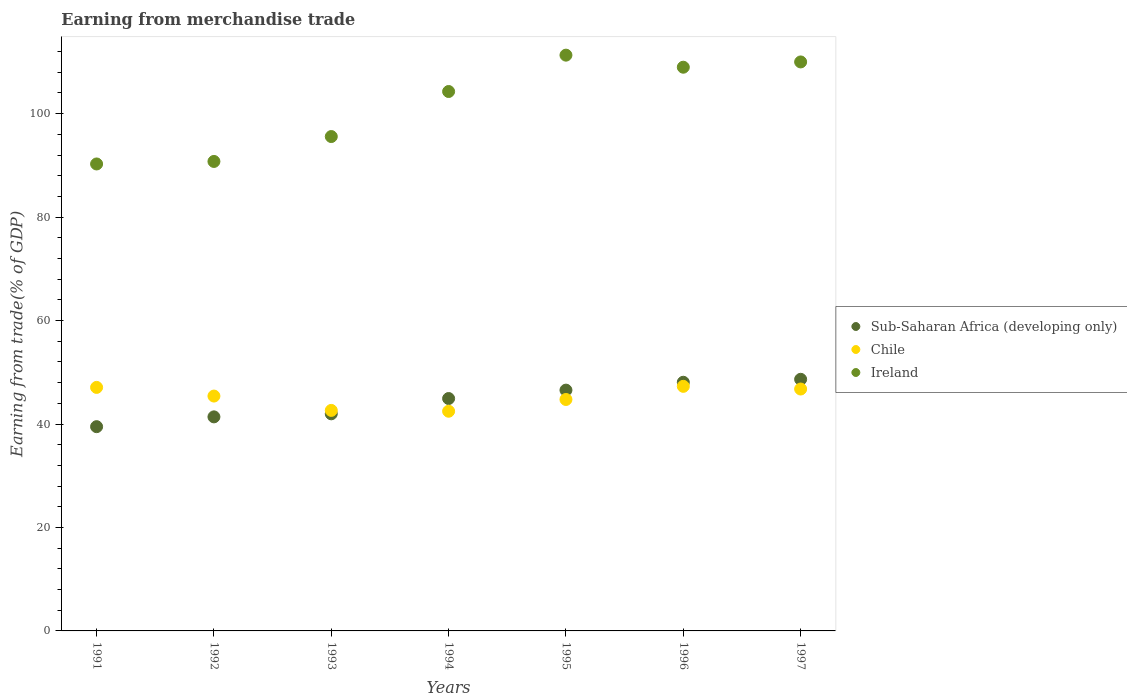What is the earnings from trade in Chile in 1991?
Keep it short and to the point. 47.08. Across all years, what is the maximum earnings from trade in Sub-Saharan Africa (developing only)?
Keep it short and to the point. 48.64. Across all years, what is the minimum earnings from trade in Chile?
Your answer should be very brief. 42.47. In which year was the earnings from trade in Ireland maximum?
Provide a short and direct response. 1995. In which year was the earnings from trade in Ireland minimum?
Offer a terse response. 1991. What is the total earnings from trade in Ireland in the graph?
Offer a very short reply. 711.17. What is the difference between the earnings from trade in Ireland in 1991 and that in 1997?
Your answer should be compact. -19.72. What is the difference between the earnings from trade in Ireland in 1997 and the earnings from trade in Sub-Saharan Africa (developing only) in 1996?
Ensure brevity in your answer.  61.93. What is the average earnings from trade in Chile per year?
Offer a terse response. 45.2. In the year 1997, what is the difference between the earnings from trade in Chile and earnings from trade in Sub-Saharan Africa (developing only)?
Your answer should be very brief. -1.88. What is the ratio of the earnings from trade in Chile in 1991 to that in 1995?
Your response must be concise. 1.05. Is the difference between the earnings from trade in Chile in 1991 and 1996 greater than the difference between the earnings from trade in Sub-Saharan Africa (developing only) in 1991 and 1996?
Your answer should be very brief. Yes. What is the difference between the highest and the second highest earnings from trade in Chile?
Your response must be concise. 0.2. What is the difference between the highest and the lowest earnings from trade in Chile?
Provide a succinct answer. 4.81. In how many years, is the earnings from trade in Chile greater than the average earnings from trade in Chile taken over all years?
Your answer should be very brief. 4. Is the earnings from trade in Ireland strictly greater than the earnings from trade in Chile over the years?
Offer a terse response. Yes. How many dotlines are there?
Offer a very short reply. 3. Are the values on the major ticks of Y-axis written in scientific E-notation?
Your answer should be compact. No. Where does the legend appear in the graph?
Ensure brevity in your answer.  Center right. How many legend labels are there?
Your answer should be compact. 3. How are the legend labels stacked?
Provide a short and direct response. Vertical. What is the title of the graph?
Keep it short and to the point. Earning from merchandise trade. What is the label or title of the X-axis?
Give a very brief answer. Years. What is the label or title of the Y-axis?
Make the answer very short. Earning from trade(% of GDP). What is the Earning from trade(% of GDP) in Sub-Saharan Africa (developing only) in 1991?
Give a very brief answer. 39.49. What is the Earning from trade(% of GDP) in Chile in 1991?
Make the answer very short. 47.08. What is the Earning from trade(% of GDP) of Ireland in 1991?
Keep it short and to the point. 90.27. What is the Earning from trade(% of GDP) in Sub-Saharan Africa (developing only) in 1992?
Offer a terse response. 41.38. What is the Earning from trade(% of GDP) of Chile in 1992?
Your answer should be very brief. 45.4. What is the Earning from trade(% of GDP) in Ireland in 1992?
Provide a succinct answer. 90.76. What is the Earning from trade(% of GDP) of Sub-Saharan Africa (developing only) in 1993?
Keep it short and to the point. 41.97. What is the Earning from trade(% of GDP) in Chile in 1993?
Your response must be concise. 42.63. What is the Earning from trade(% of GDP) in Ireland in 1993?
Your answer should be compact. 95.57. What is the Earning from trade(% of GDP) in Sub-Saharan Africa (developing only) in 1994?
Keep it short and to the point. 44.93. What is the Earning from trade(% of GDP) of Chile in 1994?
Your answer should be very brief. 42.47. What is the Earning from trade(% of GDP) of Ireland in 1994?
Provide a short and direct response. 104.28. What is the Earning from trade(% of GDP) in Sub-Saharan Africa (developing only) in 1995?
Provide a succinct answer. 46.55. What is the Earning from trade(% of GDP) in Chile in 1995?
Your answer should be very brief. 44.74. What is the Earning from trade(% of GDP) of Ireland in 1995?
Provide a short and direct response. 111.31. What is the Earning from trade(% of GDP) in Sub-Saharan Africa (developing only) in 1996?
Give a very brief answer. 48.07. What is the Earning from trade(% of GDP) in Chile in 1996?
Give a very brief answer. 47.28. What is the Earning from trade(% of GDP) of Ireland in 1996?
Make the answer very short. 108.98. What is the Earning from trade(% of GDP) in Sub-Saharan Africa (developing only) in 1997?
Make the answer very short. 48.64. What is the Earning from trade(% of GDP) of Chile in 1997?
Offer a terse response. 46.76. What is the Earning from trade(% of GDP) of Ireland in 1997?
Ensure brevity in your answer.  110. Across all years, what is the maximum Earning from trade(% of GDP) in Sub-Saharan Africa (developing only)?
Offer a terse response. 48.64. Across all years, what is the maximum Earning from trade(% of GDP) in Chile?
Provide a succinct answer. 47.28. Across all years, what is the maximum Earning from trade(% of GDP) in Ireland?
Your answer should be very brief. 111.31. Across all years, what is the minimum Earning from trade(% of GDP) of Sub-Saharan Africa (developing only)?
Keep it short and to the point. 39.49. Across all years, what is the minimum Earning from trade(% of GDP) of Chile?
Offer a very short reply. 42.47. Across all years, what is the minimum Earning from trade(% of GDP) in Ireland?
Keep it short and to the point. 90.27. What is the total Earning from trade(% of GDP) in Sub-Saharan Africa (developing only) in the graph?
Ensure brevity in your answer.  311.03. What is the total Earning from trade(% of GDP) of Chile in the graph?
Provide a short and direct response. 316.37. What is the total Earning from trade(% of GDP) of Ireland in the graph?
Your answer should be very brief. 711.17. What is the difference between the Earning from trade(% of GDP) in Sub-Saharan Africa (developing only) in 1991 and that in 1992?
Keep it short and to the point. -1.9. What is the difference between the Earning from trade(% of GDP) in Chile in 1991 and that in 1992?
Give a very brief answer. 1.68. What is the difference between the Earning from trade(% of GDP) of Ireland in 1991 and that in 1992?
Provide a short and direct response. -0.49. What is the difference between the Earning from trade(% of GDP) of Sub-Saharan Africa (developing only) in 1991 and that in 1993?
Your response must be concise. -2.49. What is the difference between the Earning from trade(% of GDP) in Chile in 1991 and that in 1993?
Your response must be concise. 4.45. What is the difference between the Earning from trade(% of GDP) of Ireland in 1991 and that in 1993?
Provide a short and direct response. -5.3. What is the difference between the Earning from trade(% of GDP) in Sub-Saharan Africa (developing only) in 1991 and that in 1994?
Offer a very short reply. -5.44. What is the difference between the Earning from trade(% of GDP) in Chile in 1991 and that in 1994?
Your answer should be very brief. 4.61. What is the difference between the Earning from trade(% of GDP) in Ireland in 1991 and that in 1994?
Provide a succinct answer. -14.01. What is the difference between the Earning from trade(% of GDP) of Sub-Saharan Africa (developing only) in 1991 and that in 1995?
Keep it short and to the point. -7.06. What is the difference between the Earning from trade(% of GDP) in Chile in 1991 and that in 1995?
Your answer should be very brief. 2.34. What is the difference between the Earning from trade(% of GDP) of Ireland in 1991 and that in 1995?
Provide a short and direct response. -21.04. What is the difference between the Earning from trade(% of GDP) in Sub-Saharan Africa (developing only) in 1991 and that in 1996?
Offer a terse response. -8.59. What is the difference between the Earning from trade(% of GDP) in Chile in 1991 and that in 1996?
Make the answer very short. -0.2. What is the difference between the Earning from trade(% of GDP) in Ireland in 1991 and that in 1996?
Offer a very short reply. -18.7. What is the difference between the Earning from trade(% of GDP) in Sub-Saharan Africa (developing only) in 1991 and that in 1997?
Make the answer very short. -9.16. What is the difference between the Earning from trade(% of GDP) of Chile in 1991 and that in 1997?
Provide a succinct answer. 0.32. What is the difference between the Earning from trade(% of GDP) of Ireland in 1991 and that in 1997?
Your response must be concise. -19.72. What is the difference between the Earning from trade(% of GDP) of Sub-Saharan Africa (developing only) in 1992 and that in 1993?
Give a very brief answer. -0.59. What is the difference between the Earning from trade(% of GDP) of Chile in 1992 and that in 1993?
Offer a very short reply. 2.77. What is the difference between the Earning from trade(% of GDP) of Ireland in 1992 and that in 1993?
Your answer should be very brief. -4.81. What is the difference between the Earning from trade(% of GDP) of Sub-Saharan Africa (developing only) in 1992 and that in 1994?
Keep it short and to the point. -3.54. What is the difference between the Earning from trade(% of GDP) in Chile in 1992 and that in 1994?
Give a very brief answer. 2.93. What is the difference between the Earning from trade(% of GDP) in Ireland in 1992 and that in 1994?
Ensure brevity in your answer.  -13.52. What is the difference between the Earning from trade(% of GDP) of Sub-Saharan Africa (developing only) in 1992 and that in 1995?
Provide a short and direct response. -5.17. What is the difference between the Earning from trade(% of GDP) of Chile in 1992 and that in 1995?
Make the answer very short. 0.66. What is the difference between the Earning from trade(% of GDP) of Ireland in 1992 and that in 1995?
Offer a terse response. -20.55. What is the difference between the Earning from trade(% of GDP) in Sub-Saharan Africa (developing only) in 1992 and that in 1996?
Keep it short and to the point. -6.69. What is the difference between the Earning from trade(% of GDP) in Chile in 1992 and that in 1996?
Offer a terse response. -1.88. What is the difference between the Earning from trade(% of GDP) of Ireland in 1992 and that in 1996?
Offer a very short reply. -18.22. What is the difference between the Earning from trade(% of GDP) of Sub-Saharan Africa (developing only) in 1992 and that in 1997?
Offer a terse response. -7.26. What is the difference between the Earning from trade(% of GDP) of Chile in 1992 and that in 1997?
Provide a short and direct response. -1.36. What is the difference between the Earning from trade(% of GDP) in Ireland in 1992 and that in 1997?
Give a very brief answer. -19.24. What is the difference between the Earning from trade(% of GDP) of Sub-Saharan Africa (developing only) in 1993 and that in 1994?
Provide a short and direct response. -2.95. What is the difference between the Earning from trade(% of GDP) in Chile in 1993 and that in 1994?
Provide a short and direct response. 0.16. What is the difference between the Earning from trade(% of GDP) in Ireland in 1993 and that in 1994?
Keep it short and to the point. -8.71. What is the difference between the Earning from trade(% of GDP) of Sub-Saharan Africa (developing only) in 1993 and that in 1995?
Your answer should be very brief. -4.58. What is the difference between the Earning from trade(% of GDP) in Chile in 1993 and that in 1995?
Your answer should be compact. -2.11. What is the difference between the Earning from trade(% of GDP) in Ireland in 1993 and that in 1995?
Provide a short and direct response. -15.74. What is the difference between the Earning from trade(% of GDP) of Sub-Saharan Africa (developing only) in 1993 and that in 1996?
Provide a short and direct response. -6.1. What is the difference between the Earning from trade(% of GDP) of Chile in 1993 and that in 1996?
Offer a terse response. -4.65. What is the difference between the Earning from trade(% of GDP) of Ireland in 1993 and that in 1996?
Offer a very short reply. -13.4. What is the difference between the Earning from trade(% of GDP) in Sub-Saharan Africa (developing only) in 1993 and that in 1997?
Offer a terse response. -6.67. What is the difference between the Earning from trade(% of GDP) in Chile in 1993 and that in 1997?
Offer a very short reply. -4.13. What is the difference between the Earning from trade(% of GDP) in Ireland in 1993 and that in 1997?
Your response must be concise. -14.42. What is the difference between the Earning from trade(% of GDP) of Sub-Saharan Africa (developing only) in 1994 and that in 1995?
Make the answer very short. -1.62. What is the difference between the Earning from trade(% of GDP) in Chile in 1994 and that in 1995?
Your response must be concise. -2.27. What is the difference between the Earning from trade(% of GDP) of Ireland in 1994 and that in 1995?
Your response must be concise. -7.03. What is the difference between the Earning from trade(% of GDP) of Sub-Saharan Africa (developing only) in 1994 and that in 1996?
Your response must be concise. -3.14. What is the difference between the Earning from trade(% of GDP) in Chile in 1994 and that in 1996?
Your answer should be very brief. -4.81. What is the difference between the Earning from trade(% of GDP) in Ireland in 1994 and that in 1996?
Your answer should be very brief. -4.7. What is the difference between the Earning from trade(% of GDP) of Sub-Saharan Africa (developing only) in 1994 and that in 1997?
Make the answer very short. -3.72. What is the difference between the Earning from trade(% of GDP) of Chile in 1994 and that in 1997?
Give a very brief answer. -4.29. What is the difference between the Earning from trade(% of GDP) in Ireland in 1994 and that in 1997?
Your response must be concise. -5.72. What is the difference between the Earning from trade(% of GDP) in Sub-Saharan Africa (developing only) in 1995 and that in 1996?
Offer a terse response. -1.52. What is the difference between the Earning from trade(% of GDP) of Chile in 1995 and that in 1996?
Offer a very short reply. -2.54. What is the difference between the Earning from trade(% of GDP) in Ireland in 1995 and that in 1996?
Keep it short and to the point. 2.33. What is the difference between the Earning from trade(% of GDP) in Sub-Saharan Africa (developing only) in 1995 and that in 1997?
Keep it short and to the point. -2.09. What is the difference between the Earning from trade(% of GDP) of Chile in 1995 and that in 1997?
Offer a very short reply. -2.02. What is the difference between the Earning from trade(% of GDP) of Ireland in 1995 and that in 1997?
Provide a succinct answer. 1.31. What is the difference between the Earning from trade(% of GDP) of Sub-Saharan Africa (developing only) in 1996 and that in 1997?
Your response must be concise. -0.57. What is the difference between the Earning from trade(% of GDP) of Chile in 1996 and that in 1997?
Ensure brevity in your answer.  0.52. What is the difference between the Earning from trade(% of GDP) in Ireland in 1996 and that in 1997?
Ensure brevity in your answer.  -1.02. What is the difference between the Earning from trade(% of GDP) of Sub-Saharan Africa (developing only) in 1991 and the Earning from trade(% of GDP) of Chile in 1992?
Ensure brevity in your answer.  -5.92. What is the difference between the Earning from trade(% of GDP) of Sub-Saharan Africa (developing only) in 1991 and the Earning from trade(% of GDP) of Ireland in 1992?
Offer a very short reply. -51.27. What is the difference between the Earning from trade(% of GDP) in Chile in 1991 and the Earning from trade(% of GDP) in Ireland in 1992?
Provide a succinct answer. -43.68. What is the difference between the Earning from trade(% of GDP) of Sub-Saharan Africa (developing only) in 1991 and the Earning from trade(% of GDP) of Chile in 1993?
Keep it short and to the point. -3.14. What is the difference between the Earning from trade(% of GDP) of Sub-Saharan Africa (developing only) in 1991 and the Earning from trade(% of GDP) of Ireland in 1993?
Your response must be concise. -56.09. What is the difference between the Earning from trade(% of GDP) of Chile in 1991 and the Earning from trade(% of GDP) of Ireland in 1993?
Offer a very short reply. -48.49. What is the difference between the Earning from trade(% of GDP) in Sub-Saharan Africa (developing only) in 1991 and the Earning from trade(% of GDP) in Chile in 1994?
Ensure brevity in your answer.  -2.98. What is the difference between the Earning from trade(% of GDP) of Sub-Saharan Africa (developing only) in 1991 and the Earning from trade(% of GDP) of Ireland in 1994?
Your answer should be very brief. -64.79. What is the difference between the Earning from trade(% of GDP) in Chile in 1991 and the Earning from trade(% of GDP) in Ireland in 1994?
Provide a short and direct response. -57.2. What is the difference between the Earning from trade(% of GDP) of Sub-Saharan Africa (developing only) in 1991 and the Earning from trade(% of GDP) of Chile in 1995?
Ensure brevity in your answer.  -5.26. What is the difference between the Earning from trade(% of GDP) in Sub-Saharan Africa (developing only) in 1991 and the Earning from trade(% of GDP) in Ireland in 1995?
Keep it short and to the point. -71.82. What is the difference between the Earning from trade(% of GDP) in Chile in 1991 and the Earning from trade(% of GDP) in Ireland in 1995?
Provide a succinct answer. -64.23. What is the difference between the Earning from trade(% of GDP) in Sub-Saharan Africa (developing only) in 1991 and the Earning from trade(% of GDP) in Chile in 1996?
Give a very brief answer. -7.8. What is the difference between the Earning from trade(% of GDP) in Sub-Saharan Africa (developing only) in 1991 and the Earning from trade(% of GDP) in Ireland in 1996?
Make the answer very short. -69.49. What is the difference between the Earning from trade(% of GDP) of Chile in 1991 and the Earning from trade(% of GDP) of Ireland in 1996?
Give a very brief answer. -61.9. What is the difference between the Earning from trade(% of GDP) in Sub-Saharan Africa (developing only) in 1991 and the Earning from trade(% of GDP) in Chile in 1997?
Your answer should be compact. -7.28. What is the difference between the Earning from trade(% of GDP) of Sub-Saharan Africa (developing only) in 1991 and the Earning from trade(% of GDP) of Ireland in 1997?
Your response must be concise. -70.51. What is the difference between the Earning from trade(% of GDP) of Chile in 1991 and the Earning from trade(% of GDP) of Ireland in 1997?
Offer a very short reply. -62.92. What is the difference between the Earning from trade(% of GDP) of Sub-Saharan Africa (developing only) in 1992 and the Earning from trade(% of GDP) of Chile in 1993?
Your answer should be very brief. -1.25. What is the difference between the Earning from trade(% of GDP) of Sub-Saharan Africa (developing only) in 1992 and the Earning from trade(% of GDP) of Ireland in 1993?
Keep it short and to the point. -54.19. What is the difference between the Earning from trade(% of GDP) of Chile in 1992 and the Earning from trade(% of GDP) of Ireland in 1993?
Offer a very short reply. -50.17. What is the difference between the Earning from trade(% of GDP) in Sub-Saharan Africa (developing only) in 1992 and the Earning from trade(% of GDP) in Chile in 1994?
Keep it short and to the point. -1.09. What is the difference between the Earning from trade(% of GDP) of Sub-Saharan Africa (developing only) in 1992 and the Earning from trade(% of GDP) of Ireland in 1994?
Make the answer very short. -62.9. What is the difference between the Earning from trade(% of GDP) in Chile in 1992 and the Earning from trade(% of GDP) in Ireland in 1994?
Provide a short and direct response. -58.88. What is the difference between the Earning from trade(% of GDP) in Sub-Saharan Africa (developing only) in 1992 and the Earning from trade(% of GDP) in Chile in 1995?
Give a very brief answer. -3.36. What is the difference between the Earning from trade(% of GDP) of Sub-Saharan Africa (developing only) in 1992 and the Earning from trade(% of GDP) of Ireland in 1995?
Offer a very short reply. -69.93. What is the difference between the Earning from trade(% of GDP) of Chile in 1992 and the Earning from trade(% of GDP) of Ireland in 1995?
Make the answer very short. -65.91. What is the difference between the Earning from trade(% of GDP) of Sub-Saharan Africa (developing only) in 1992 and the Earning from trade(% of GDP) of Chile in 1996?
Your answer should be very brief. -5.9. What is the difference between the Earning from trade(% of GDP) of Sub-Saharan Africa (developing only) in 1992 and the Earning from trade(% of GDP) of Ireland in 1996?
Your response must be concise. -67.59. What is the difference between the Earning from trade(% of GDP) of Chile in 1992 and the Earning from trade(% of GDP) of Ireland in 1996?
Offer a very short reply. -63.57. What is the difference between the Earning from trade(% of GDP) in Sub-Saharan Africa (developing only) in 1992 and the Earning from trade(% of GDP) in Chile in 1997?
Offer a terse response. -5.38. What is the difference between the Earning from trade(% of GDP) in Sub-Saharan Africa (developing only) in 1992 and the Earning from trade(% of GDP) in Ireland in 1997?
Provide a succinct answer. -68.62. What is the difference between the Earning from trade(% of GDP) of Chile in 1992 and the Earning from trade(% of GDP) of Ireland in 1997?
Offer a very short reply. -64.59. What is the difference between the Earning from trade(% of GDP) in Sub-Saharan Africa (developing only) in 1993 and the Earning from trade(% of GDP) in Chile in 1994?
Offer a terse response. -0.5. What is the difference between the Earning from trade(% of GDP) in Sub-Saharan Africa (developing only) in 1993 and the Earning from trade(% of GDP) in Ireland in 1994?
Provide a succinct answer. -62.31. What is the difference between the Earning from trade(% of GDP) in Chile in 1993 and the Earning from trade(% of GDP) in Ireland in 1994?
Give a very brief answer. -61.65. What is the difference between the Earning from trade(% of GDP) in Sub-Saharan Africa (developing only) in 1993 and the Earning from trade(% of GDP) in Chile in 1995?
Ensure brevity in your answer.  -2.77. What is the difference between the Earning from trade(% of GDP) in Sub-Saharan Africa (developing only) in 1993 and the Earning from trade(% of GDP) in Ireland in 1995?
Your response must be concise. -69.34. What is the difference between the Earning from trade(% of GDP) in Chile in 1993 and the Earning from trade(% of GDP) in Ireland in 1995?
Offer a very short reply. -68.68. What is the difference between the Earning from trade(% of GDP) of Sub-Saharan Africa (developing only) in 1993 and the Earning from trade(% of GDP) of Chile in 1996?
Your answer should be compact. -5.31. What is the difference between the Earning from trade(% of GDP) in Sub-Saharan Africa (developing only) in 1993 and the Earning from trade(% of GDP) in Ireland in 1996?
Your response must be concise. -67. What is the difference between the Earning from trade(% of GDP) of Chile in 1993 and the Earning from trade(% of GDP) of Ireland in 1996?
Your answer should be compact. -66.35. What is the difference between the Earning from trade(% of GDP) of Sub-Saharan Africa (developing only) in 1993 and the Earning from trade(% of GDP) of Chile in 1997?
Offer a terse response. -4.79. What is the difference between the Earning from trade(% of GDP) in Sub-Saharan Africa (developing only) in 1993 and the Earning from trade(% of GDP) in Ireland in 1997?
Offer a very short reply. -68.03. What is the difference between the Earning from trade(% of GDP) of Chile in 1993 and the Earning from trade(% of GDP) of Ireland in 1997?
Your answer should be compact. -67.37. What is the difference between the Earning from trade(% of GDP) of Sub-Saharan Africa (developing only) in 1994 and the Earning from trade(% of GDP) of Chile in 1995?
Your answer should be very brief. 0.18. What is the difference between the Earning from trade(% of GDP) in Sub-Saharan Africa (developing only) in 1994 and the Earning from trade(% of GDP) in Ireland in 1995?
Keep it short and to the point. -66.38. What is the difference between the Earning from trade(% of GDP) of Chile in 1994 and the Earning from trade(% of GDP) of Ireland in 1995?
Offer a very short reply. -68.84. What is the difference between the Earning from trade(% of GDP) in Sub-Saharan Africa (developing only) in 1994 and the Earning from trade(% of GDP) in Chile in 1996?
Provide a short and direct response. -2.36. What is the difference between the Earning from trade(% of GDP) in Sub-Saharan Africa (developing only) in 1994 and the Earning from trade(% of GDP) in Ireland in 1996?
Make the answer very short. -64.05. What is the difference between the Earning from trade(% of GDP) in Chile in 1994 and the Earning from trade(% of GDP) in Ireland in 1996?
Make the answer very short. -66.51. What is the difference between the Earning from trade(% of GDP) in Sub-Saharan Africa (developing only) in 1994 and the Earning from trade(% of GDP) in Chile in 1997?
Provide a short and direct response. -1.84. What is the difference between the Earning from trade(% of GDP) of Sub-Saharan Africa (developing only) in 1994 and the Earning from trade(% of GDP) of Ireland in 1997?
Make the answer very short. -65.07. What is the difference between the Earning from trade(% of GDP) in Chile in 1994 and the Earning from trade(% of GDP) in Ireland in 1997?
Offer a terse response. -67.53. What is the difference between the Earning from trade(% of GDP) of Sub-Saharan Africa (developing only) in 1995 and the Earning from trade(% of GDP) of Chile in 1996?
Offer a terse response. -0.73. What is the difference between the Earning from trade(% of GDP) of Sub-Saharan Africa (developing only) in 1995 and the Earning from trade(% of GDP) of Ireland in 1996?
Ensure brevity in your answer.  -62.43. What is the difference between the Earning from trade(% of GDP) of Chile in 1995 and the Earning from trade(% of GDP) of Ireland in 1996?
Provide a succinct answer. -64.23. What is the difference between the Earning from trade(% of GDP) of Sub-Saharan Africa (developing only) in 1995 and the Earning from trade(% of GDP) of Chile in 1997?
Give a very brief answer. -0.21. What is the difference between the Earning from trade(% of GDP) of Sub-Saharan Africa (developing only) in 1995 and the Earning from trade(% of GDP) of Ireland in 1997?
Your answer should be compact. -63.45. What is the difference between the Earning from trade(% of GDP) in Chile in 1995 and the Earning from trade(% of GDP) in Ireland in 1997?
Provide a short and direct response. -65.25. What is the difference between the Earning from trade(% of GDP) in Sub-Saharan Africa (developing only) in 1996 and the Earning from trade(% of GDP) in Chile in 1997?
Provide a short and direct response. 1.31. What is the difference between the Earning from trade(% of GDP) of Sub-Saharan Africa (developing only) in 1996 and the Earning from trade(% of GDP) of Ireland in 1997?
Make the answer very short. -61.93. What is the difference between the Earning from trade(% of GDP) in Chile in 1996 and the Earning from trade(% of GDP) in Ireland in 1997?
Your answer should be compact. -62.71. What is the average Earning from trade(% of GDP) in Sub-Saharan Africa (developing only) per year?
Provide a succinct answer. 44.43. What is the average Earning from trade(% of GDP) of Chile per year?
Ensure brevity in your answer.  45.2. What is the average Earning from trade(% of GDP) in Ireland per year?
Your answer should be compact. 101.59. In the year 1991, what is the difference between the Earning from trade(% of GDP) of Sub-Saharan Africa (developing only) and Earning from trade(% of GDP) of Chile?
Offer a terse response. -7.59. In the year 1991, what is the difference between the Earning from trade(% of GDP) of Sub-Saharan Africa (developing only) and Earning from trade(% of GDP) of Ireland?
Keep it short and to the point. -50.79. In the year 1991, what is the difference between the Earning from trade(% of GDP) in Chile and Earning from trade(% of GDP) in Ireland?
Offer a very short reply. -43.19. In the year 1992, what is the difference between the Earning from trade(% of GDP) of Sub-Saharan Africa (developing only) and Earning from trade(% of GDP) of Chile?
Make the answer very short. -4.02. In the year 1992, what is the difference between the Earning from trade(% of GDP) in Sub-Saharan Africa (developing only) and Earning from trade(% of GDP) in Ireland?
Keep it short and to the point. -49.38. In the year 1992, what is the difference between the Earning from trade(% of GDP) of Chile and Earning from trade(% of GDP) of Ireland?
Make the answer very short. -45.36. In the year 1993, what is the difference between the Earning from trade(% of GDP) of Sub-Saharan Africa (developing only) and Earning from trade(% of GDP) of Chile?
Offer a terse response. -0.66. In the year 1993, what is the difference between the Earning from trade(% of GDP) in Sub-Saharan Africa (developing only) and Earning from trade(% of GDP) in Ireland?
Your response must be concise. -53.6. In the year 1993, what is the difference between the Earning from trade(% of GDP) in Chile and Earning from trade(% of GDP) in Ireland?
Your response must be concise. -52.94. In the year 1994, what is the difference between the Earning from trade(% of GDP) of Sub-Saharan Africa (developing only) and Earning from trade(% of GDP) of Chile?
Provide a short and direct response. 2.46. In the year 1994, what is the difference between the Earning from trade(% of GDP) of Sub-Saharan Africa (developing only) and Earning from trade(% of GDP) of Ireland?
Your answer should be compact. -59.35. In the year 1994, what is the difference between the Earning from trade(% of GDP) in Chile and Earning from trade(% of GDP) in Ireland?
Provide a succinct answer. -61.81. In the year 1995, what is the difference between the Earning from trade(% of GDP) of Sub-Saharan Africa (developing only) and Earning from trade(% of GDP) of Chile?
Make the answer very short. 1.81. In the year 1995, what is the difference between the Earning from trade(% of GDP) of Sub-Saharan Africa (developing only) and Earning from trade(% of GDP) of Ireland?
Offer a terse response. -64.76. In the year 1995, what is the difference between the Earning from trade(% of GDP) in Chile and Earning from trade(% of GDP) in Ireland?
Your response must be concise. -66.57. In the year 1996, what is the difference between the Earning from trade(% of GDP) in Sub-Saharan Africa (developing only) and Earning from trade(% of GDP) in Chile?
Your answer should be very brief. 0.79. In the year 1996, what is the difference between the Earning from trade(% of GDP) in Sub-Saharan Africa (developing only) and Earning from trade(% of GDP) in Ireland?
Keep it short and to the point. -60.91. In the year 1996, what is the difference between the Earning from trade(% of GDP) of Chile and Earning from trade(% of GDP) of Ireland?
Your response must be concise. -61.69. In the year 1997, what is the difference between the Earning from trade(% of GDP) in Sub-Saharan Africa (developing only) and Earning from trade(% of GDP) in Chile?
Offer a very short reply. 1.88. In the year 1997, what is the difference between the Earning from trade(% of GDP) of Sub-Saharan Africa (developing only) and Earning from trade(% of GDP) of Ireland?
Provide a short and direct response. -61.35. In the year 1997, what is the difference between the Earning from trade(% of GDP) of Chile and Earning from trade(% of GDP) of Ireland?
Give a very brief answer. -63.23. What is the ratio of the Earning from trade(% of GDP) of Sub-Saharan Africa (developing only) in 1991 to that in 1992?
Give a very brief answer. 0.95. What is the ratio of the Earning from trade(% of GDP) of Chile in 1991 to that in 1992?
Give a very brief answer. 1.04. What is the ratio of the Earning from trade(% of GDP) of Ireland in 1991 to that in 1992?
Provide a succinct answer. 0.99. What is the ratio of the Earning from trade(% of GDP) in Sub-Saharan Africa (developing only) in 1991 to that in 1993?
Provide a short and direct response. 0.94. What is the ratio of the Earning from trade(% of GDP) of Chile in 1991 to that in 1993?
Your response must be concise. 1.1. What is the ratio of the Earning from trade(% of GDP) in Ireland in 1991 to that in 1993?
Offer a very short reply. 0.94. What is the ratio of the Earning from trade(% of GDP) in Sub-Saharan Africa (developing only) in 1991 to that in 1994?
Make the answer very short. 0.88. What is the ratio of the Earning from trade(% of GDP) in Chile in 1991 to that in 1994?
Ensure brevity in your answer.  1.11. What is the ratio of the Earning from trade(% of GDP) of Ireland in 1991 to that in 1994?
Provide a short and direct response. 0.87. What is the ratio of the Earning from trade(% of GDP) in Sub-Saharan Africa (developing only) in 1991 to that in 1995?
Ensure brevity in your answer.  0.85. What is the ratio of the Earning from trade(% of GDP) in Chile in 1991 to that in 1995?
Provide a short and direct response. 1.05. What is the ratio of the Earning from trade(% of GDP) in Ireland in 1991 to that in 1995?
Provide a succinct answer. 0.81. What is the ratio of the Earning from trade(% of GDP) in Sub-Saharan Africa (developing only) in 1991 to that in 1996?
Make the answer very short. 0.82. What is the ratio of the Earning from trade(% of GDP) of Chile in 1991 to that in 1996?
Your response must be concise. 1. What is the ratio of the Earning from trade(% of GDP) in Ireland in 1991 to that in 1996?
Ensure brevity in your answer.  0.83. What is the ratio of the Earning from trade(% of GDP) in Sub-Saharan Africa (developing only) in 1991 to that in 1997?
Provide a short and direct response. 0.81. What is the ratio of the Earning from trade(% of GDP) of Chile in 1991 to that in 1997?
Ensure brevity in your answer.  1.01. What is the ratio of the Earning from trade(% of GDP) in Ireland in 1991 to that in 1997?
Provide a short and direct response. 0.82. What is the ratio of the Earning from trade(% of GDP) in Sub-Saharan Africa (developing only) in 1992 to that in 1993?
Offer a terse response. 0.99. What is the ratio of the Earning from trade(% of GDP) in Chile in 1992 to that in 1993?
Your answer should be very brief. 1.07. What is the ratio of the Earning from trade(% of GDP) of Ireland in 1992 to that in 1993?
Your answer should be very brief. 0.95. What is the ratio of the Earning from trade(% of GDP) in Sub-Saharan Africa (developing only) in 1992 to that in 1994?
Make the answer very short. 0.92. What is the ratio of the Earning from trade(% of GDP) of Chile in 1992 to that in 1994?
Provide a short and direct response. 1.07. What is the ratio of the Earning from trade(% of GDP) of Ireland in 1992 to that in 1994?
Ensure brevity in your answer.  0.87. What is the ratio of the Earning from trade(% of GDP) in Sub-Saharan Africa (developing only) in 1992 to that in 1995?
Your answer should be very brief. 0.89. What is the ratio of the Earning from trade(% of GDP) of Chile in 1992 to that in 1995?
Provide a short and direct response. 1.01. What is the ratio of the Earning from trade(% of GDP) of Ireland in 1992 to that in 1995?
Ensure brevity in your answer.  0.82. What is the ratio of the Earning from trade(% of GDP) of Sub-Saharan Africa (developing only) in 1992 to that in 1996?
Offer a very short reply. 0.86. What is the ratio of the Earning from trade(% of GDP) of Chile in 1992 to that in 1996?
Your answer should be very brief. 0.96. What is the ratio of the Earning from trade(% of GDP) in Ireland in 1992 to that in 1996?
Ensure brevity in your answer.  0.83. What is the ratio of the Earning from trade(% of GDP) of Sub-Saharan Africa (developing only) in 1992 to that in 1997?
Keep it short and to the point. 0.85. What is the ratio of the Earning from trade(% of GDP) of Chile in 1992 to that in 1997?
Ensure brevity in your answer.  0.97. What is the ratio of the Earning from trade(% of GDP) in Ireland in 1992 to that in 1997?
Give a very brief answer. 0.83. What is the ratio of the Earning from trade(% of GDP) of Sub-Saharan Africa (developing only) in 1993 to that in 1994?
Provide a succinct answer. 0.93. What is the ratio of the Earning from trade(% of GDP) in Ireland in 1993 to that in 1994?
Your response must be concise. 0.92. What is the ratio of the Earning from trade(% of GDP) in Sub-Saharan Africa (developing only) in 1993 to that in 1995?
Provide a succinct answer. 0.9. What is the ratio of the Earning from trade(% of GDP) in Chile in 1993 to that in 1995?
Make the answer very short. 0.95. What is the ratio of the Earning from trade(% of GDP) in Ireland in 1993 to that in 1995?
Your answer should be compact. 0.86. What is the ratio of the Earning from trade(% of GDP) of Sub-Saharan Africa (developing only) in 1993 to that in 1996?
Ensure brevity in your answer.  0.87. What is the ratio of the Earning from trade(% of GDP) in Chile in 1993 to that in 1996?
Offer a very short reply. 0.9. What is the ratio of the Earning from trade(% of GDP) of Ireland in 1993 to that in 1996?
Make the answer very short. 0.88. What is the ratio of the Earning from trade(% of GDP) of Sub-Saharan Africa (developing only) in 1993 to that in 1997?
Make the answer very short. 0.86. What is the ratio of the Earning from trade(% of GDP) in Chile in 1993 to that in 1997?
Offer a terse response. 0.91. What is the ratio of the Earning from trade(% of GDP) of Ireland in 1993 to that in 1997?
Your answer should be very brief. 0.87. What is the ratio of the Earning from trade(% of GDP) of Sub-Saharan Africa (developing only) in 1994 to that in 1995?
Your answer should be compact. 0.97. What is the ratio of the Earning from trade(% of GDP) of Chile in 1994 to that in 1995?
Provide a short and direct response. 0.95. What is the ratio of the Earning from trade(% of GDP) of Ireland in 1994 to that in 1995?
Your answer should be very brief. 0.94. What is the ratio of the Earning from trade(% of GDP) in Sub-Saharan Africa (developing only) in 1994 to that in 1996?
Offer a very short reply. 0.93. What is the ratio of the Earning from trade(% of GDP) in Chile in 1994 to that in 1996?
Give a very brief answer. 0.9. What is the ratio of the Earning from trade(% of GDP) of Ireland in 1994 to that in 1996?
Provide a short and direct response. 0.96. What is the ratio of the Earning from trade(% of GDP) in Sub-Saharan Africa (developing only) in 1994 to that in 1997?
Keep it short and to the point. 0.92. What is the ratio of the Earning from trade(% of GDP) of Chile in 1994 to that in 1997?
Provide a succinct answer. 0.91. What is the ratio of the Earning from trade(% of GDP) of Ireland in 1994 to that in 1997?
Provide a succinct answer. 0.95. What is the ratio of the Earning from trade(% of GDP) of Sub-Saharan Africa (developing only) in 1995 to that in 1996?
Ensure brevity in your answer.  0.97. What is the ratio of the Earning from trade(% of GDP) of Chile in 1995 to that in 1996?
Your answer should be very brief. 0.95. What is the ratio of the Earning from trade(% of GDP) in Ireland in 1995 to that in 1996?
Ensure brevity in your answer.  1.02. What is the ratio of the Earning from trade(% of GDP) of Sub-Saharan Africa (developing only) in 1995 to that in 1997?
Your answer should be very brief. 0.96. What is the ratio of the Earning from trade(% of GDP) in Chile in 1995 to that in 1997?
Give a very brief answer. 0.96. What is the ratio of the Earning from trade(% of GDP) in Ireland in 1995 to that in 1997?
Provide a succinct answer. 1.01. What is the ratio of the Earning from trade(% of GDP) of Sub-Saharan Africa (developing only) in 1996 to that in 1997?
Ensure brevity in your answer.  0.99. What is the ratio of the Earning from trade(% of GDP) of Chile in 1996 to that in 1997?
Provide a succinct answer. 1.01. What is the difference between the highest and the second highest Earning from trade(% of GDP) in Sub-Saharan Africa (developing only)?
Your answer should be compact. 0.57. What is the difference between the highest and the second highest Earning from trade(% of GDP) of Chile?
Your response must be concise. 0.2. What is the difference between the highest and the second highest Earning from trade(% of GDP) of Ireland?
Your answer should be compact. 1.31. What is the difference between the highest and the lowest Earning from trade(% of GDP) of Sub-Saharan Africa (developing only)?
Provide a succinct answer. 9.16. What is the difference between the highest and the lowest Earning from trade(% of GDP) of Chile?
Provide a succinct answer. 4.81. What is the difference between the highest and the lowest Earning from trade(% of GDP) in Ireland?
Your answer should be very brief. 21.04. 